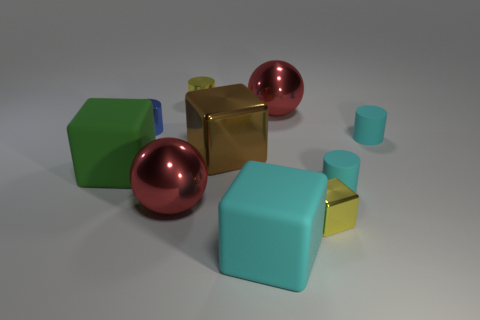Subtract all red cylinders. Subtract all yellow balls. How many cylinders are left? 4 Subtract all cylinders. How many objects are left? 6 Subtract all cyan cylinders. Subtract all tiny cylinders. How many objects are left? 4 Add 3 large brown metal cubes. How many large brown metal cubes are left? 4 Add 7 red objects. How many red objects exist? 9 Subtract 1 cyan blocks. How many objects are left? 9 